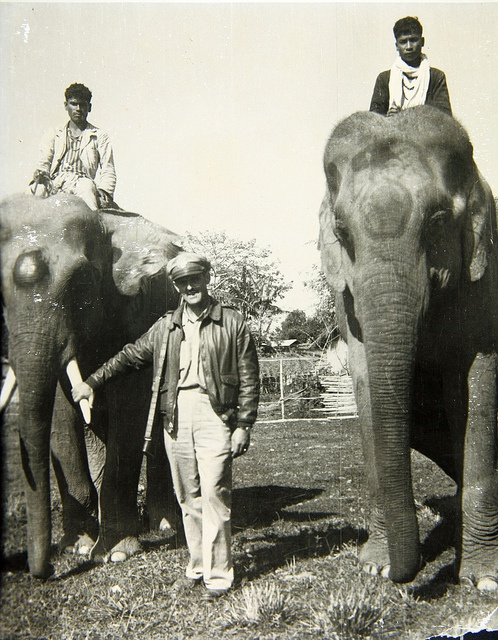Describe the objects in this image and their specific colors. I can see elephant in white, black, gray, and darkgray tones, elephant in white, black, gray, darkgray, and lightgray tones, people in white, beige, gray, black, and darkgray tones, people in white, ivory, darkgray, gray, and beige tones, and people in white, ivory, black, gray, and darkgreen tones in this image. 